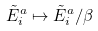Convert formula to latex. <formula><loc_0><loc_0><loc_500><loc_500>\tilde { E } _ { i } ^ { a } \mapsto \tilde { E } _ { i } ^ { a } / \beta</formula> 